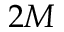Convert formula to latex. <formula><loc_0><loc_0><loc_500><loc_500>2 M</formula> 